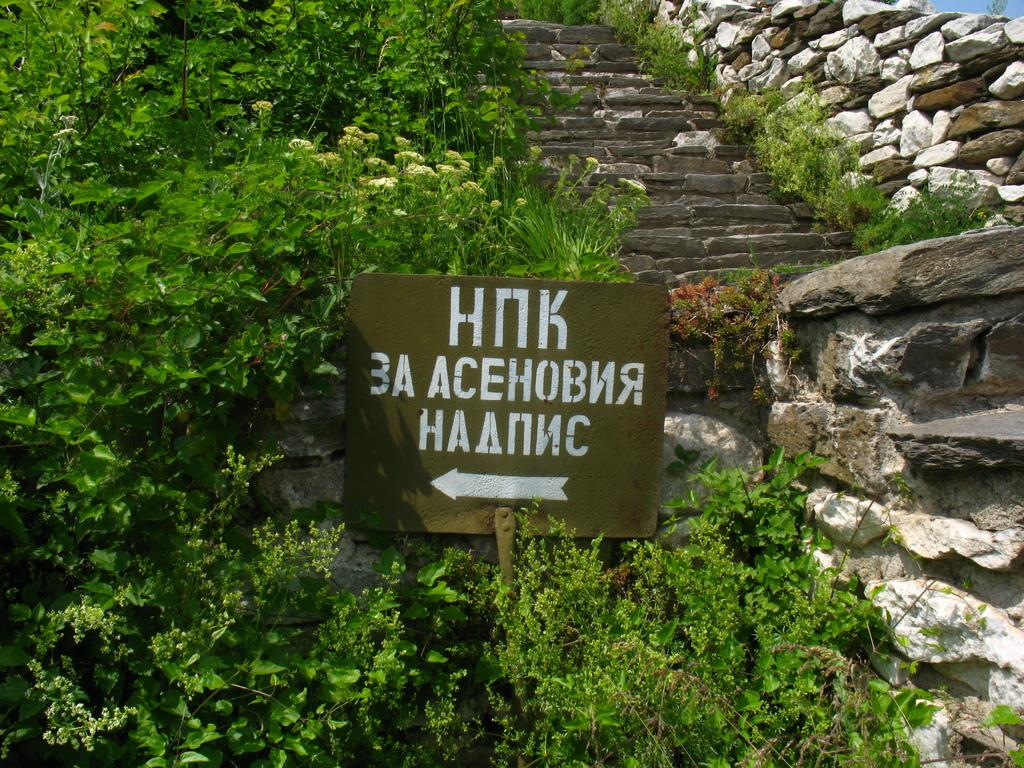What type of natural elements can be seen in the image? There are trees in the image. What type of man-made elements can be seen in the image? There are stones, stairs, and a board in the image. What is the purpose of the stairs in the image? The stairs provide access to a higher level or area. What is written on the board in the image? Something is written on the board, but the specific content is not mentioned in the facts. How many sheep are present in the flock in the image? There is no flock of sheep present in the image; it features trees, stones, stairs, and a board. 